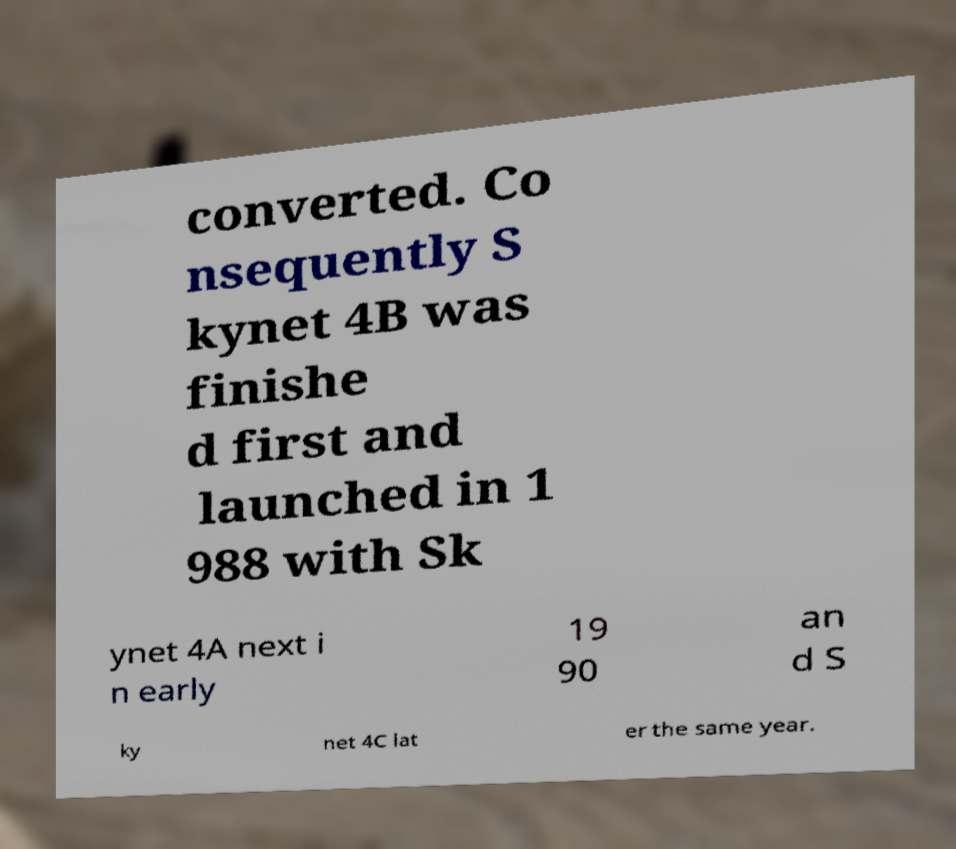I need the written content from this picture converted into text. Can you do that? converted. Co nsequently S kynet 4B was finishe d first and launched in 1 988 with Sk ynet 4A next i n early 19 90 an d S ky net 4C lat er the same year. 